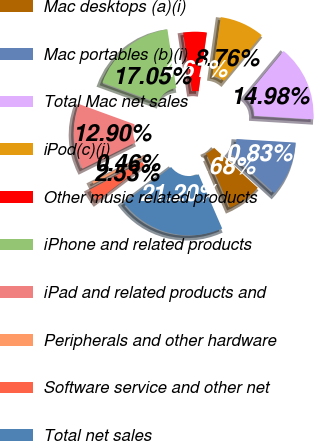<chart> <loc_0><loc_0><loc_500><loc_500><pie_chart><fcel>Mac desktops (a)(i)<fcel>Mac portables (b)(i)<fcel>Total Mac net sales<fcel>iPod(c)(i)<fcel>Other music related products<fcel>iPhone and related products<fcel>iPad and related products and<fcel>Peripherals and other hardware<fcel>Software service and other net<fcel>Total net sales<nl><fcel>6.68%<fcel>10.83%<fcel>14.98%<fcel>8.76%<fcel>4.61%<fcel>17.05%<fcel>12.9%<fcel>0.46%<fcel>2.53%<fcel>21.2%<nl></chart> 